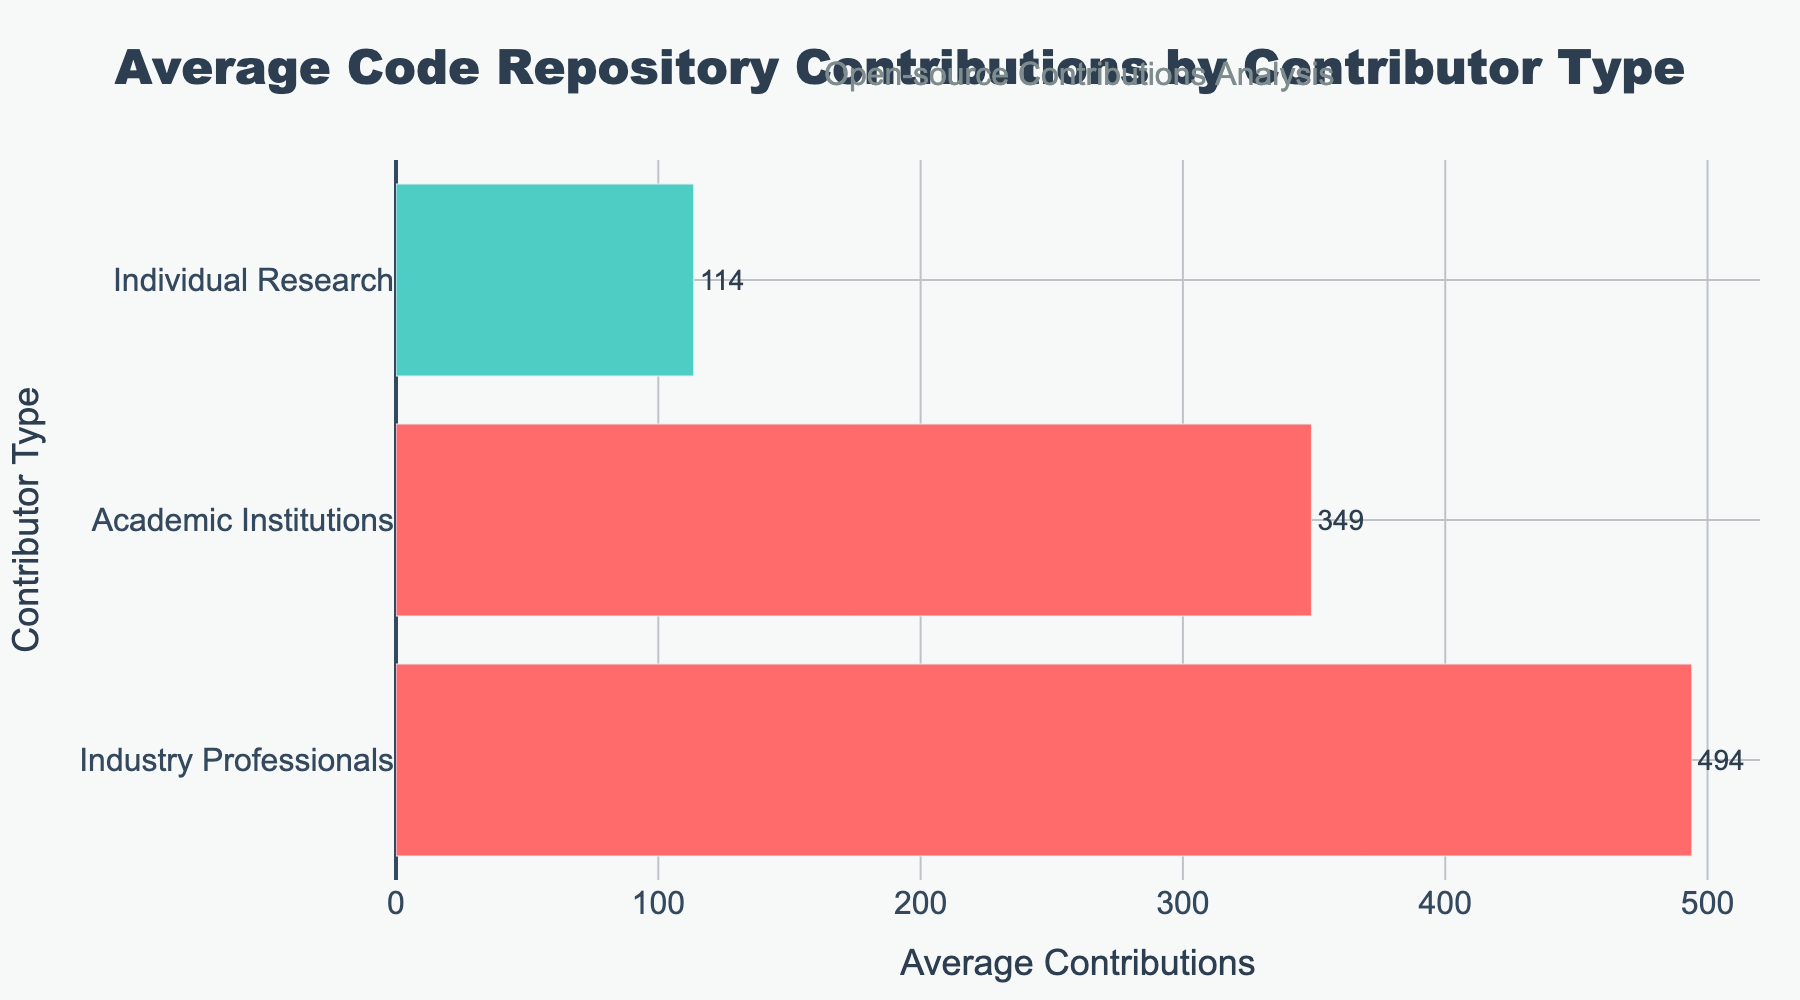What is the average contribution level of industry professionals? To find the average contribution level of industry professionals, locate the bar labeled 'Industry Professionals', note the value indicated at the end of the bar, which is the average.
Answer: 494 Which contributor type has the lowest average contributions? By observing the lengths of the bars, the shortest bar represents the contributor type with the lowest average contributions. The bar for 'Individual Research' is the shortest.
Answer: Individual Research Which contributor type exceeds the overall mean contribution level? The colors indicate divergence from the mean: above-average contributions are in red, whilst below-average are in green. Industry Professionals and Academic Institutions fall above the overall mean.
Answer: Industry Professionals, Academic Institutions Which contributor type is closest to the average contribution level and what is that approximate value? Look at the figure and identify the bar color closest to the overall average color division point. Academic Institutions appear closest to this central value.
Answer: Academic Institutions, approximately 349 What is the median value of contributions based on the contributor types? The median is the middle value when the averages are sorted. Here the sorted order would be Individual Research (111), Academic Institutions (349), and Industry Professionals (494). The middle value is the average contributions for Academic Institutions.
Answer: 349 Are there any contributor types with contributions exactly on the mean line, and which are they? Check if any bars are split exactly at the midpoint (mean line). There are no bars that split precisely at the mean; they are either above or below it.
Answer: None How does the visual color coding help identify above/below average contributions? Red bars signify contributions above the mean, and green bars indicate below-average contributions. This visual cue helps to quickly differentiate contributor types based on performance in relation to the mean.
Answer: Red for above, Green for below 